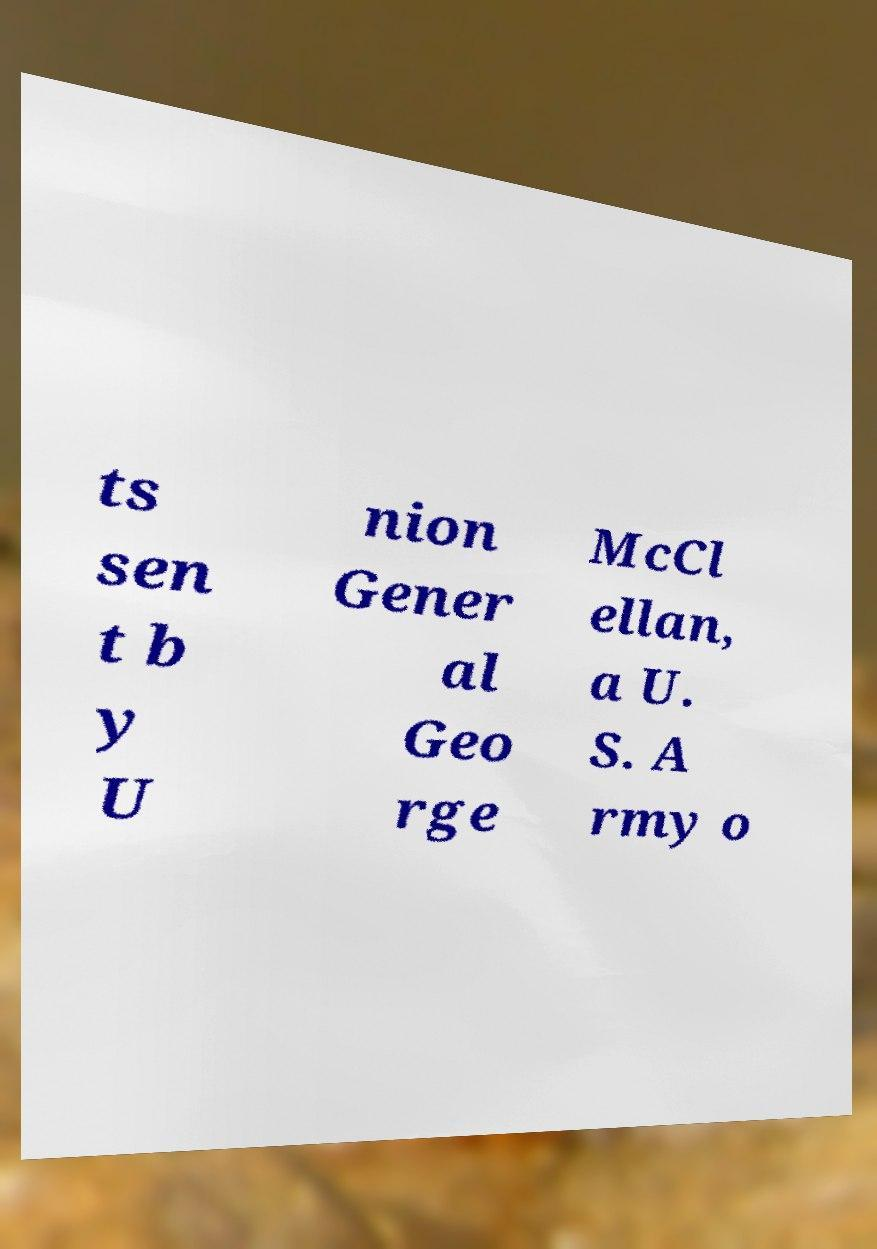I need the written content from this picture converted into text. Can you do that? ts sen t b y U nion Gener al Geo rge McCl ellan, a U. S. A rmy o 